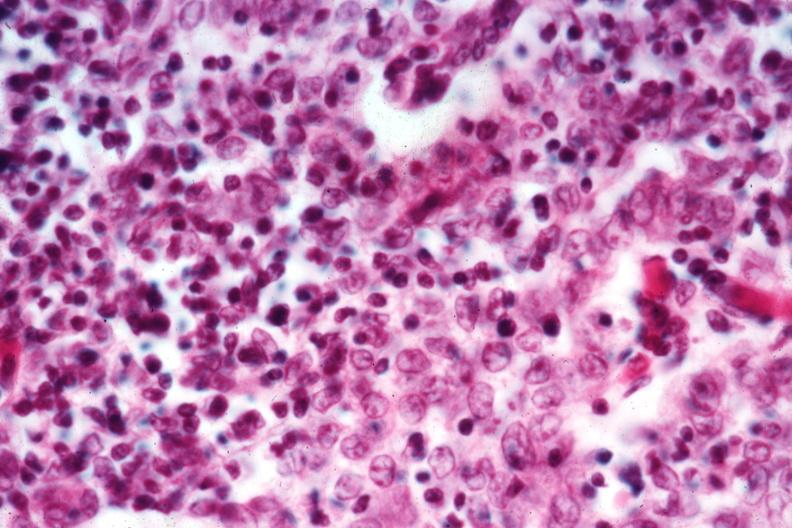does this image show cellular detail well shown?
Answer the question using a single word or phrase. Yes 